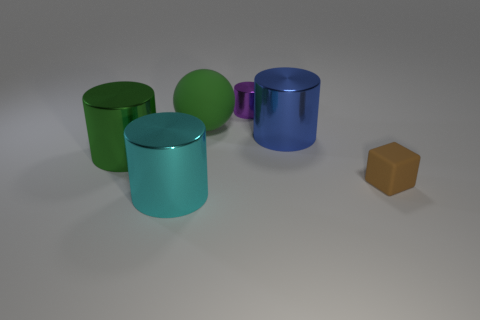Can you tell me the number of geometric shapes displayed in the image? Certainly! The image features a total of five geometric shapes. There are four cylinders, each with varying heights and colors, and one cube. The cylinders showcase a glossy finish, whereas the cube has a matte surface. 